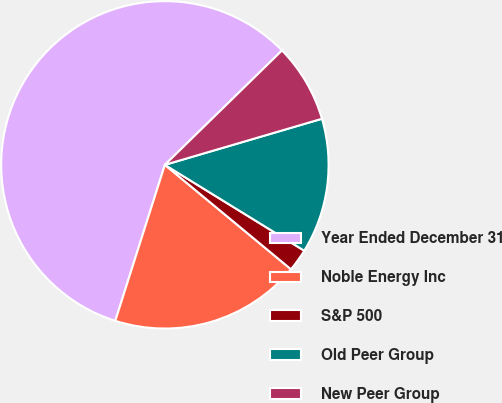Convert chart. <chart><loc_0><loc_0><loc_500><loc_500><pie_chart><fcel>Year Ended December 31<fcel>Noble Energy Inc<fcel>S&P 500<fcel>Old Peer Group<fcel>New Peer Group<nl><fcel>57.79%<fcel>18.89%<fcel>2.22%<fcel>13.33%<fcel>7.77%<nl></chart> 